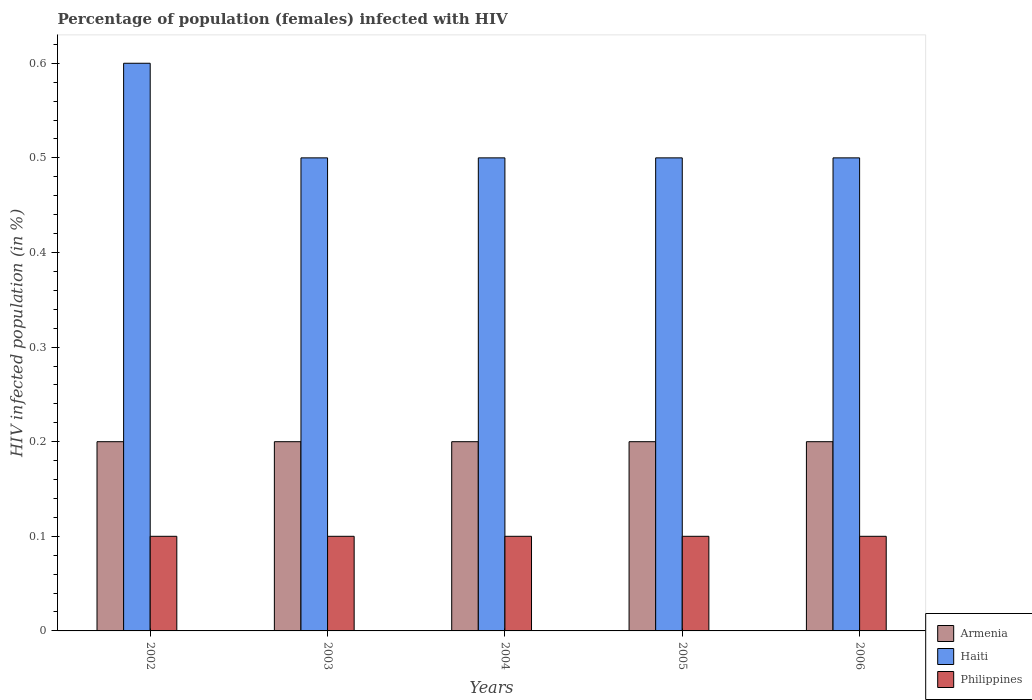How many different coloured bars are there?
Ensure brevity in your answer.  3. How many groups of bars are there?
Make the answer very short. 5. Are the number of bars per tick equal to the number of legend labels?
Your response must be concise. Yes. What is the label of the 2nd group of bars from the left?
Ensure brevity in your answer.  2003. What is the percentage of HIV infected female population in Haiti in 2004?
Provide a succinct answer. 0.5. In which year was the percentage of HIV infected female population in Philippines minimum?
Your response must be concise. 2002. What is the total percentage of HIV infected female population in Philippines in the graph?
Make the answer very short. 0.5. What is the difference between the percentage of HIV infected female population in Armenia in 2002 and that in 2006?
Keep it short and to the point. 0. What is the average percentage of HIV infected female population in Haiti per year?
Make the answer very short. 0.52. In the year 2004, what is the difference between the percentage of HIV infected female population in Philippines and percentage of HIV infected female population in Haiti?
Provide a succinct answer. -0.4. What is the ratio of the percentage of HIV infected female population in Haiti in 2004 to that in 2006?
Provide a succinct answer. 1. Is the difference between the percentage of HIV infected female population in Philippines in 2003 and 2004 greater than the difference between the percentage of HIV infected female population in Haiti in 2003 and 2004?
Keep it short and to the point. No. What is the difference between the highest and the lowest percentage of HIV infected female population in Philippines?
Your response must be concise. 0. What does the 3rd bar from the right in 2005 represents?
Offer a terse response. Armenia. Is it the case that in every year, the sum of the percentage of HIV infected female population in Haiti and percentage of HIV infected female population in Armenia is greater than the percentage of HIV infected female population in Philippines?
Your answer should be very brief. Yes. How many bars are there?
Make the answer very short. 15. How many years are there in the graph?
Offer a terse response. 5. Does the graph contain any zero values?
Make the answer very short. No. How many legend labels are there?
Your answer should be compact. 3. How are the legend labels stacked?
Ensure brevity in your answer.  Vertical. What is the title of the graph?
Ensure brevity in your answer.  Percentage of population (females) infected with HIV. Does "West Bank and Gaza" appear as one of the legend labels in the graph?
Give a very brief answer. No. What is the label or title of the X-axis?
Give a very brief answer. Years. What is the label or title of the Y-axis?
Provide a short and direct response. HIV infected population (in %). What is the HIV infected population (in %) in Philippines in 2002?
Your answer should be very brief. 0.1. What is the HIV infected population (in %) of Armenia in 2004?
Your answer should be very brief. 0.2. What is the HIV infected population (in %) of Haiti in 2004?
Keep it short and to the point. 0.5. What is the HIV infected population (in %) in Haiti in 2005?
Offer a terse response. 0.5. What is the HIV infected population (in %) in Haiti in 2006?
Make the answer very short. 0.5. What is the HIV infected population (in %) in Philippines in 2006?
Make the answer very short. 0.1. What is the total HIV infected population (in %) in Haiti in the graph?
Your answer should be very brief. 2.6. What is the total HIV infected population (in %) in Philippines in the graph?
Your answer should be compact. 0.5. What is the difference between the HIV infected population (in %) in Armenia in 2002 and that in 2003?
Offer a very short reply. 0. What is the difference between the HIV infected population (in %) in Philippines in 2002 and that in 2003?
Offer a terse response. 0. What is the difference between the HIV infected population (in %) in Armenia in 2002 and that in 2004?
Provide a short and direct response. 0. What is the difference between the HIV infected population (in %) of Philippines in 2002 and that in 2004?
Offer a terse response. 0. What is the difference between the HIV infected population (in %) in Armenia in 2002 and that in 2005?
Your answer should be compact. 0. What is the difference between the HIV infected population (in %) of Armenia in 2002 and that in 2006?
Offer a very short reply. 0. What is the difference between the HIV infected population (in %) in Philippines in 2003 and that in 2004?
Provide a succinct answer. 0. What is the difference between the HIV infected population (in %) in Haiti in 2003 and that in 2006?
Offer a terse response. 0. What is the difference between the HIV infected population (in %) of Philippines in 2004 and that in 2005?
Keep it short and to the point. 0. What is the difference between the HIV infected population (in %) in Haiti in 2004 and that in 2006?
Your response must be concise. 0. What is the difference between the HIV infected population (in %) in Philippines in 2004 and that in 2006?
Make the answer very short. 0. What is the difference between the HIV infected population (in %) in Haiti in 2005 and that in 2006?
Provide a succinct answer. 0. What is the difference between the HIV infected population (in %) of Philippines in 2005 and that in 2006?
Your response must be concise. 0. What is the difference between the HIV infected population (in %) in Armenia in 2002 and the HIV infected population (in %) in Haiti in 2004?
Your response must be concise. -0.3. What is the difference between the HIV infected population (in %) of Haiti in 2002 and the HIV infected population (in %) of Philippines in 2004?
Your answer should be very brief. 0.5. What is the difference between the HIV infected population (in %) of Armenia in 2002 and the HIV infected population (in %) of Haiti in 2005?
Provide a succinct answer. -0.3. What is the difference between the HIV infected population (in %) of Haiti in 2002 and the HIV infected population (in %) of Philippines in 2005?
Provide a short and direct response. 0.5. What is the difference between the HIV infected population (in %) of Armenia in 2002 and the HIV infected population (in %) of Haiti in 2006?
Offer a terse response. -0.3. What is the difference between the HIV infected population (in %) of Armenia in 2003 and the HIV infected population (in %) of Haiti in 2004?
Offer a terse response. -0.3. What is the difference between the HIV infected population (in %) of Haiti in 2003 and the HIV infected population (in %) of Philippines in 2004?
Ensure brevity in your answer.  0.4. What is the difference between the HIV infected population (in %) in Armenia in 2003 and the HIV infected population (in %) in Haiti in 2005?
Ensure brevity in your answer.  -0.3. What is the difference between the HIV infected population (in %) of Armenia in 2003 and the HIV infected population (in %) of Philippines in 2006?
Your answer should be very brief. 0.1. What is the difference between the HIV infected population (in %) of Armenia in 2004 and the HIV infected population (in %) of Haiti in 2005?
Your answer should be very brief. -0.3. What is the difference between the HIV infected population (in %) of Armenia in 2004 and the HIV infected population (in %) of Philippines in 2005?
Provide a short and direct response. 0.1. What is the difference between the HIV infected population (in %) of Haiti in 2004 and the HIV infected population (in %) of Philippines in 2005?
Keep it short and to the point. 0.4. What is the difference between the HIV infected population (in %) of Armenia in 2004 and the HIV infected population (in %) of Philippines in 2006?
Offer a terse response. 0.1. What is the difference between the HIV infected population (in %) in Haiti in 2004 and the HIV infected population (in %) in Philippines in 2006?
Keep it short and to the point. 0.4. What is the average HIV infected population (in %) of Haiti per year?
Provide a short and direct response. 0.52. What is the average HIV infected population (in %) in Philippines per year?
Provide a short and direct response. 0.1. In the year 2002, what is the difference between the HIV infected population (in %) of Armenia and HIV infected population (in %) of Philippines?
Keep it short and to the point. 0.1. In the year 2004, what is the difference between the HIV infected population (in %) in Armenia and HIV infected population (in %) in Haiti?
Offer a very short reply. -0.3. What is the ratio of the HIV infected population (in %) in Armenia in 2002 to that in 2003?
Give a very brief answer. 1. What is the ratio of the HIV infected population (in %) in Haiti in 2002 to that in 2004?
Provide a short and direct response. 1.2. What is the ratio of the HIV infected population (in %) of Philippines in 2002 to that in 2004?
Provide a succinct answer. 1. What is the ratio of the HIV infected population (in %) of Armenia in 2002 to that in 2006?
Make the answer very short. 1. What is the ratio of the HIV infected population (in %) of Haiti in 2002 to that in 2006?
Your answer should be very brief. 1.2. What is the ratio of the HIV infected population (in %) of Haiti in 2003 to that in 2004?
Your answer should be very brief. 1. What is the ratio of the HIV infected population (in %) of Armenia in 2003 to that in 2005?
Offer a terse response. 1. What is the ratio of the HIV infected population (in %) of Armenia in 2003 to that in 2006?
Your response must be concise. 1. What is the ratio of the HIV infected population (in %) of Haiti in 2003 to that in 2006?
Ensure brevity in your answer.  1. What is the ratio of the HIV infected population (in %) in Armenia in 2004 to that in 2005?
Provide a succinct answer. 1. What is the ratio of the HIV infected population (in %) in Philippines in 2004 to that in 2005?
Your answer should be compact. 1. What is the ratio of the HIV infected population (in %) of Haiti in 2004 to that in 2006?
Give a very brief answer. 1. What is the ratio of the HIV infected population (in %) in Armenia in 2005 to that in 2006?
Your answer should be very brief. 1. What is the difference between the highest and the lowest HIV infected population (in %) in Armenia?
Offer a very short reply. 0. What is the difference between the highest and the lowest HIV infected population (in %) in Philippines?
Ensure brevity in your answer.  0. 